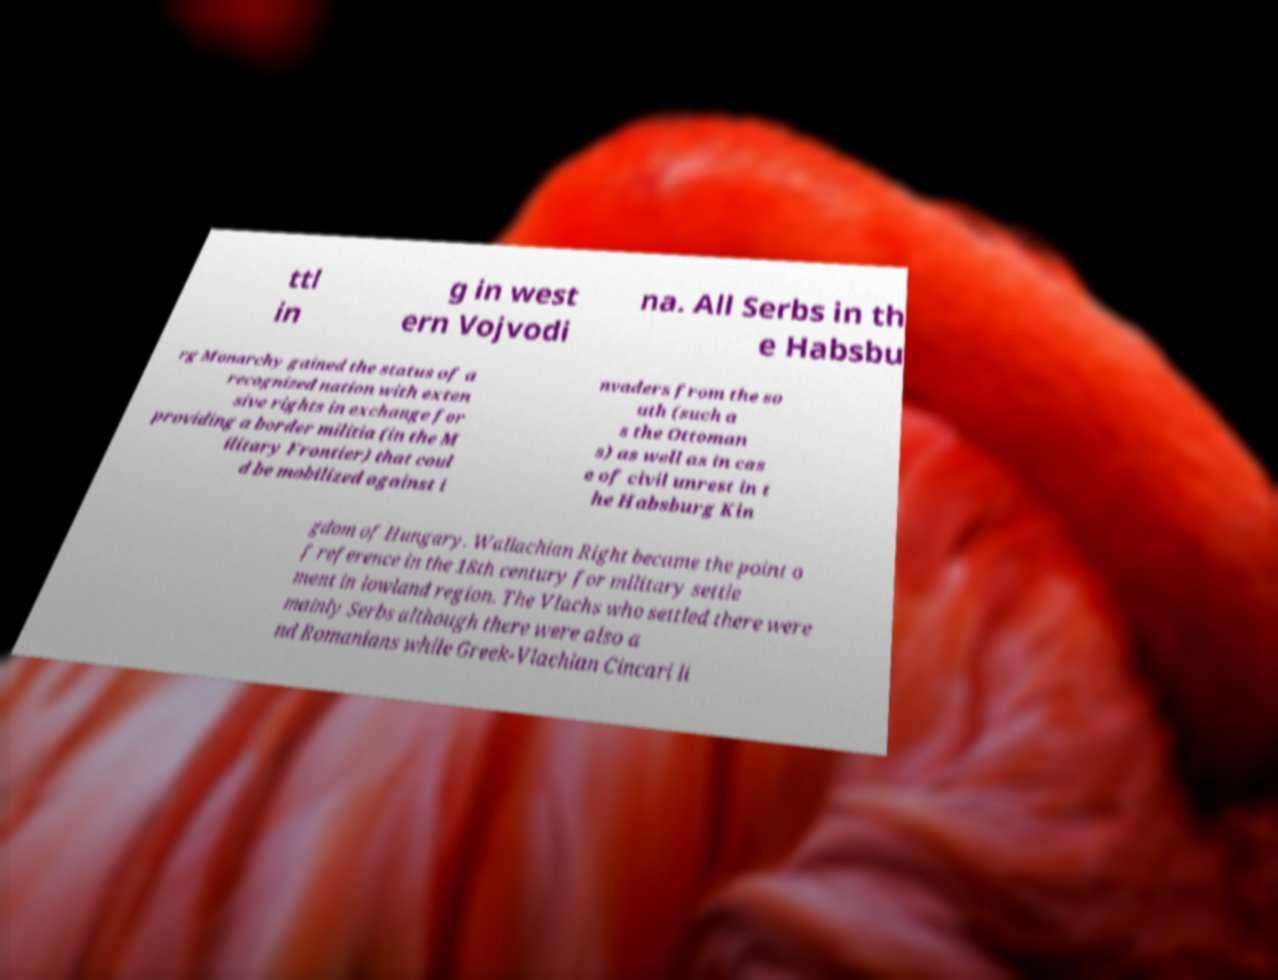Please identify and transcribe the text found in this image. ttl in g in west ern Vojvodi na. All Serbs in th e Habsbu rg Monarchy gained the status of a recognized nation with exten sive rights in exchange for providing a border militia (in the M ilitary Frontier) that coul d be mobilized against i nvaders from the so uth (such a s the Ottoman s) as well as in cas e of civil unrest in t he Habsburg Kin gdom of Hungary. Wallachian Right became the point o f reference in the 18th century for military settle ment in lowland region. The Vlachs who settled there were mainly Serbs although there were also a nd Romanians while Greek-Vlachian Cincari li 